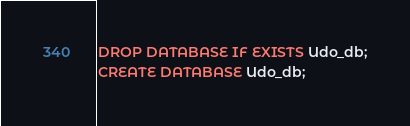Convert code to text. <code><loc_0><loc_0><loc_500><loc_500><_SQL_>DROP DATABASE IF EXISTS Udo_db;
CREATE DATABASE Udo_db;</code> 